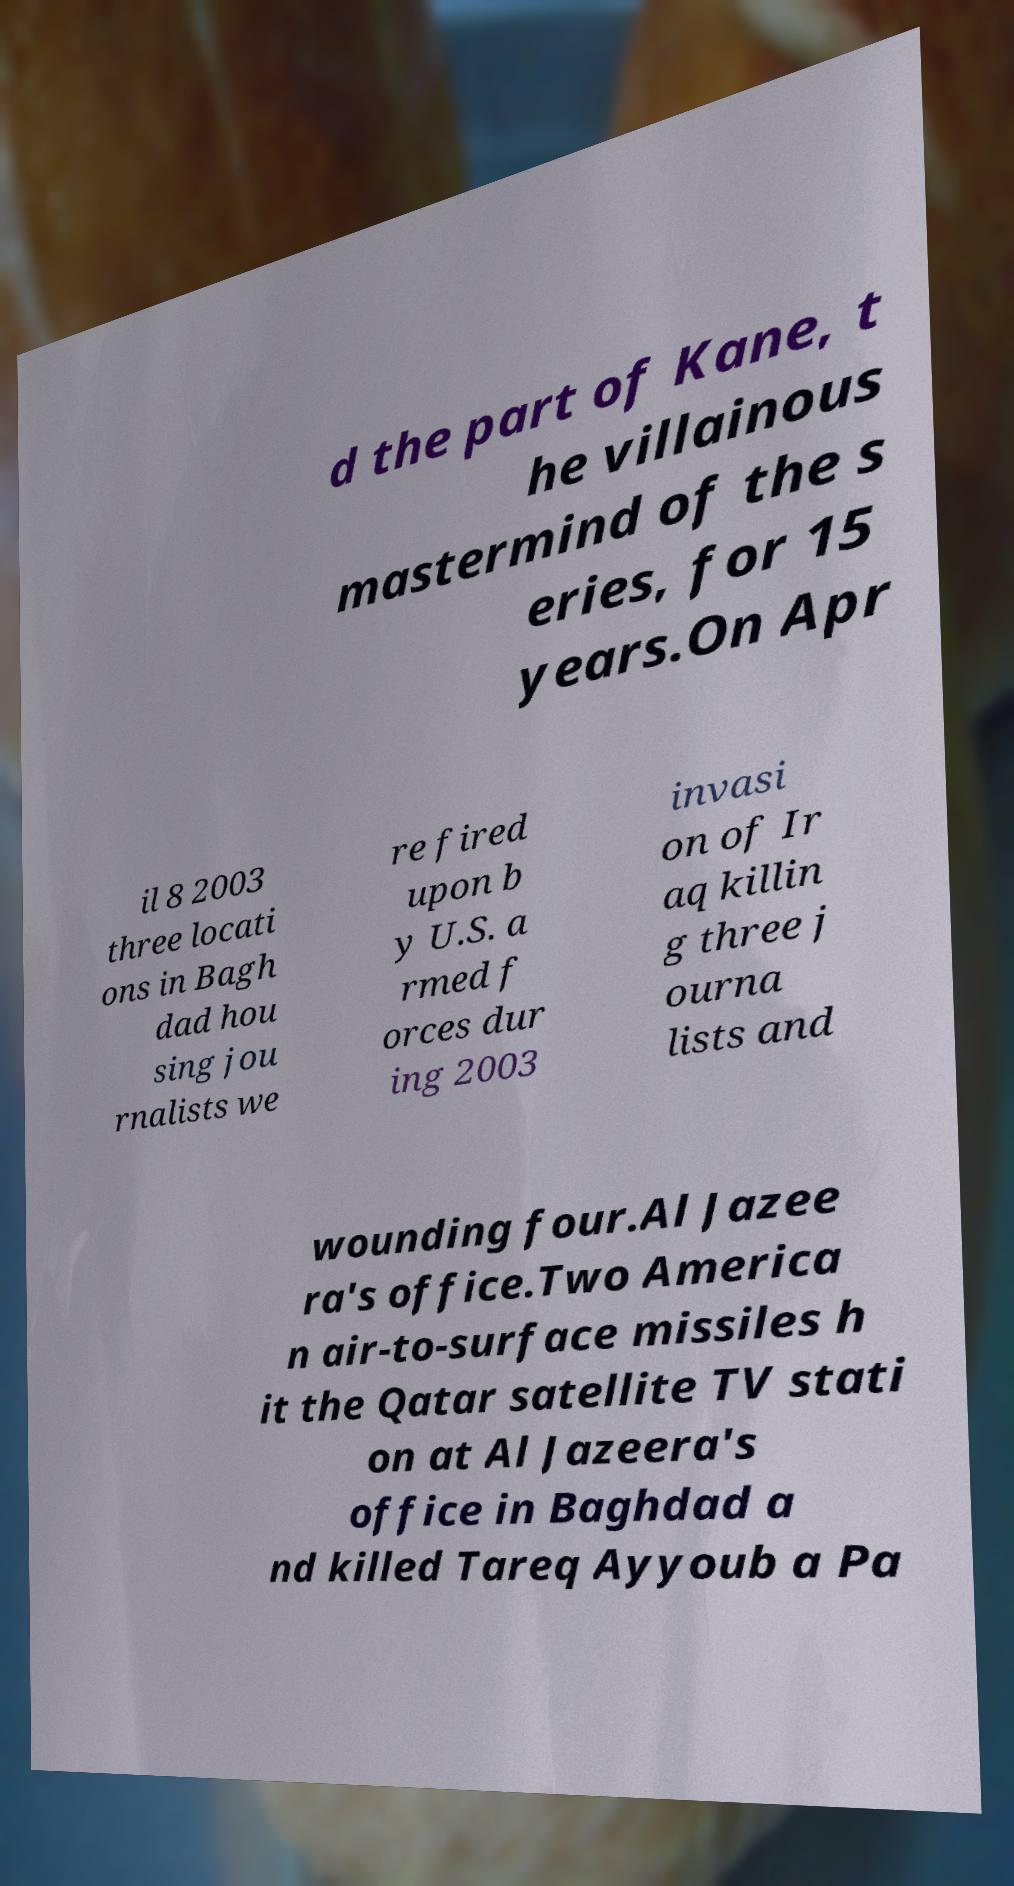There's text embedded in this image that I need extracted. Can you transcribe it verbatim? d the part of Kane, t he villainous mastermind of the s eries, for 15 years.On Apr il 8 2003 three locati ons in Bagh dad hou sing jou rnalists we re fired upon b y U.S. a rmed f orces dur ing 2003 invasi on of Ir aq killin g three j ourna lists and wounding four.Al Jazee ra's office.Two America n air-to-surface missiles h it the Qatar satellite TV stati on at Al Jazeera's office in Baghdad a nd killed Tareq Ayyoub a Pa 